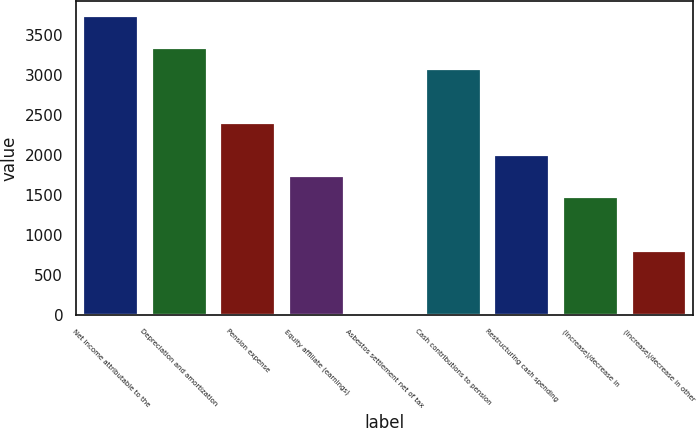Convert chart. <chart><loc_0><loc_0><loc_500><loc_500><bar_chart><fcel>Net income attributable to the<fcel>Depreciation and amortization<fcel>Pension expense<fcel>Equity affiliate (earnings)<fcel>Asbestos settlement net of tax<fcel>Cash contributions to pension<fcel>Restructuring cash spending<fcel>(Increase)/decrease in<fcel>(Increase)/decrease in other<nl><fcel>3742.2<fcel>3342<fcel>2408.2<fcel>1741.2<fcel>7<fcel>3075.2<fcel>2008<fcel>1474.4<fcel>807.4<nl></chart> 